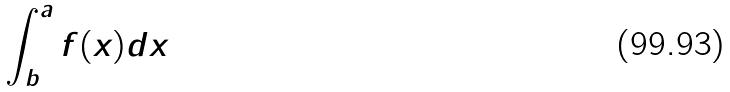Convert formula to latex. <formula><loc_0><loc_0><loc_500><loc_500>\int _ { b } ^ { a } f ( x ) d x</formula> 